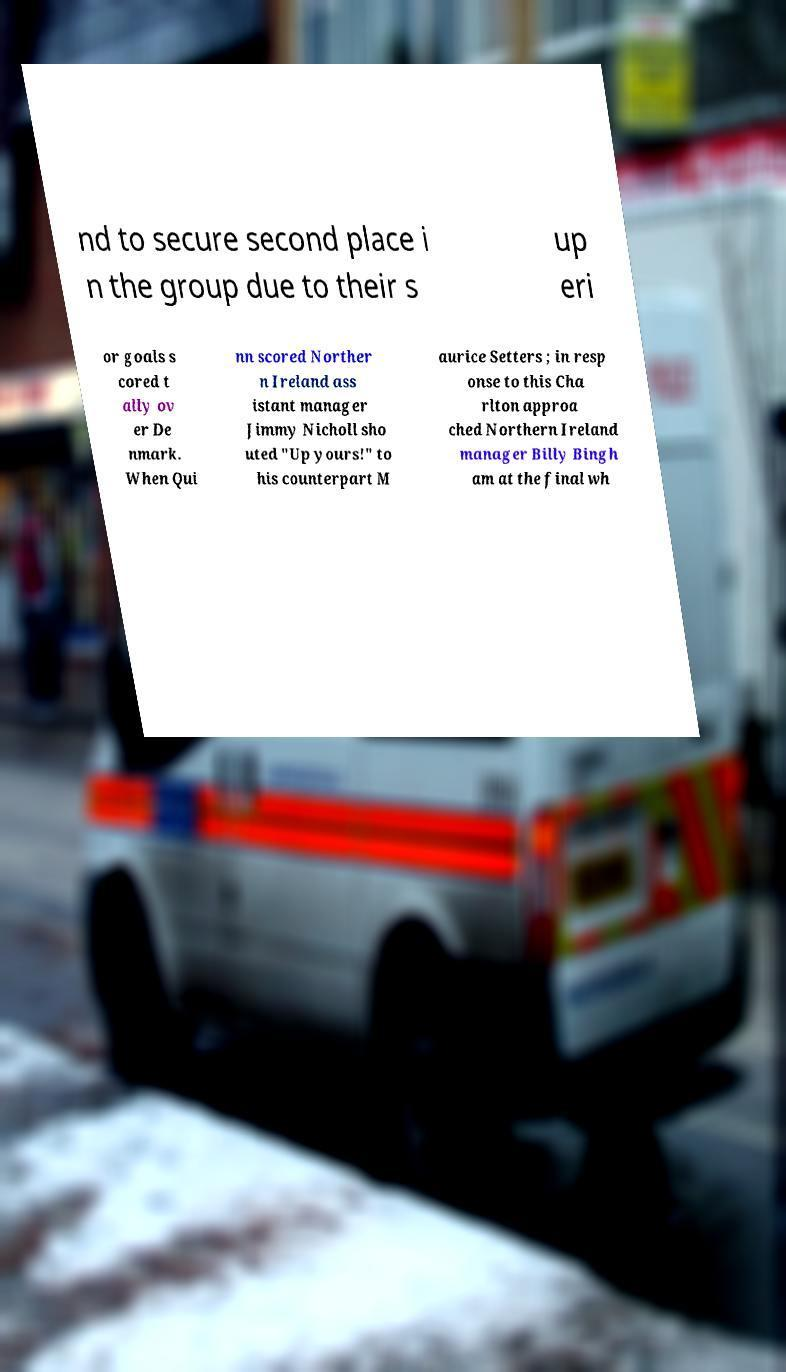Please identify and transcribe the text found in this image. nd to secure second place i n the group due to their s up eri or goals s cored t ally ov er De nmark. When Qui nn scored Norther n Ireland ass istant manager Jimmy Nicholl sho uted "Up yours!" to his counterpart M aurice Setters ; in resp onse to this Cha rlton approa ched Northern Ireland manager Billy Bingh am at the final wh 